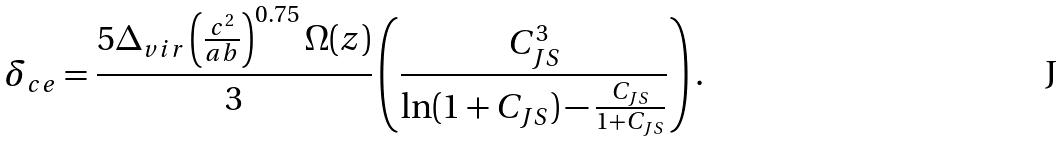<formula> <loc_0><loc_0><loc_500><loc_500>\delta _ { c e } = \frac { 5 \Delta _ { v i r } \left ( \frac { c ^ { 2 } } { a b } \right ) ^ { 0 . 7 5 } \Omega ( z ) } { 3 } \left ( \frac { C _ { J S } ^ { 3 } } { \ln ( 1 + C _ { J S } ) - \frac { C _ { J S } } { 1 + C _ { J S } } } \right ) .</formula> 